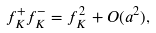<formula> <loc_0><loc_0><loc_500><loc_500>f _ { K } ^ { + } f _ { K } ^ { - } = f _ { K } ^ { 2 } + O ( a ^ { 2 } ) ,</formula> 